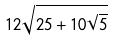Convert formula to latex. <formula><loc_0><loc_0><loc_500><loc_500>1 2 \sqrt { 2 5 + 1 0 \sqrt { 5 } }</formula> 